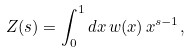Convert formula to latex. <formula><loc_0><loc_0><loc_500><loc_500>Z ( s ) = \int _ { 0 } ^ { 1 } d x \, w ( x ) \, x ^ { s - 1 } ,</formula> 